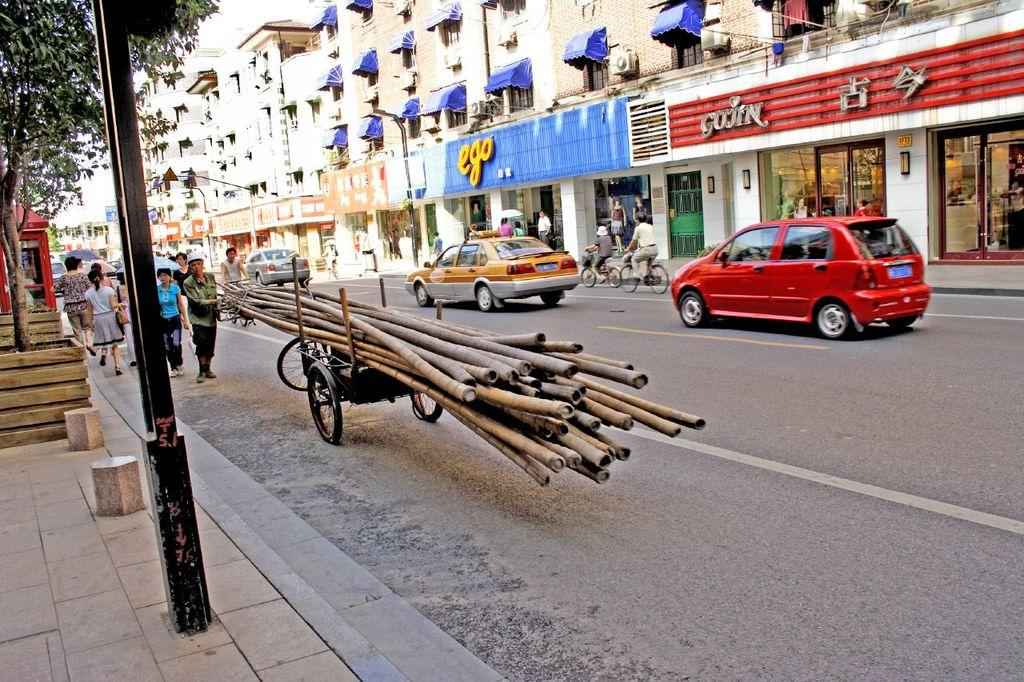<image>
Render a clear and concise summary of the photo. A person carrying a cart with logs on it in front of a store that says ego. 